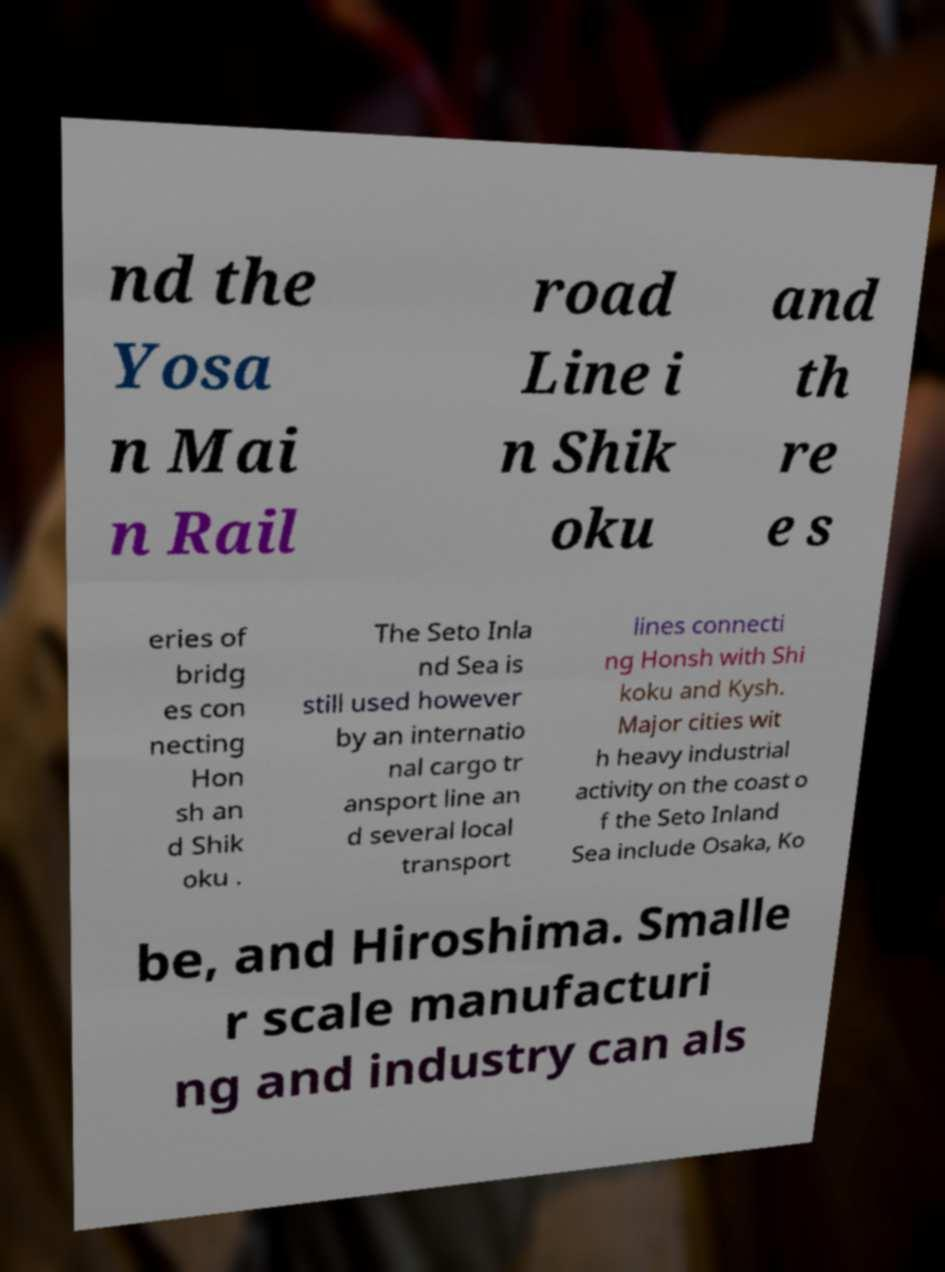Please identify and transcribe the text found in this image. nd the Yosa n Mai n Rail road Line i n Shik oku and th re e s eries of bridg es con necting Hon sh an d Shik oku . The Seto Inla nd Sea is still used however by an internatio nal cargo tr ansport line an d several local transport lines connecti ng Honsh with Shi koku and Kysh. Major cities wit h heavy industrial activity on the coast o f the Seto Inland Sea include Osaka, Ko be, and Hiroshima. Smalle r scale manufacturi ng and industry can als 